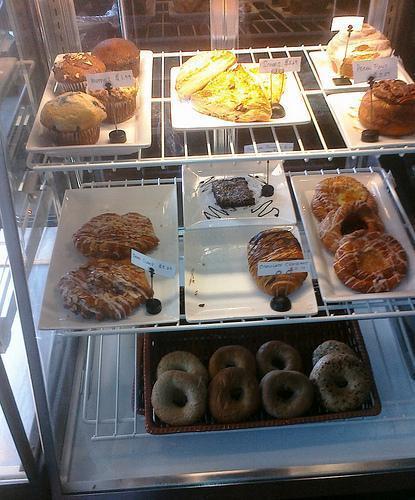How many donuts are there?
Give a very brief answer. 8. 